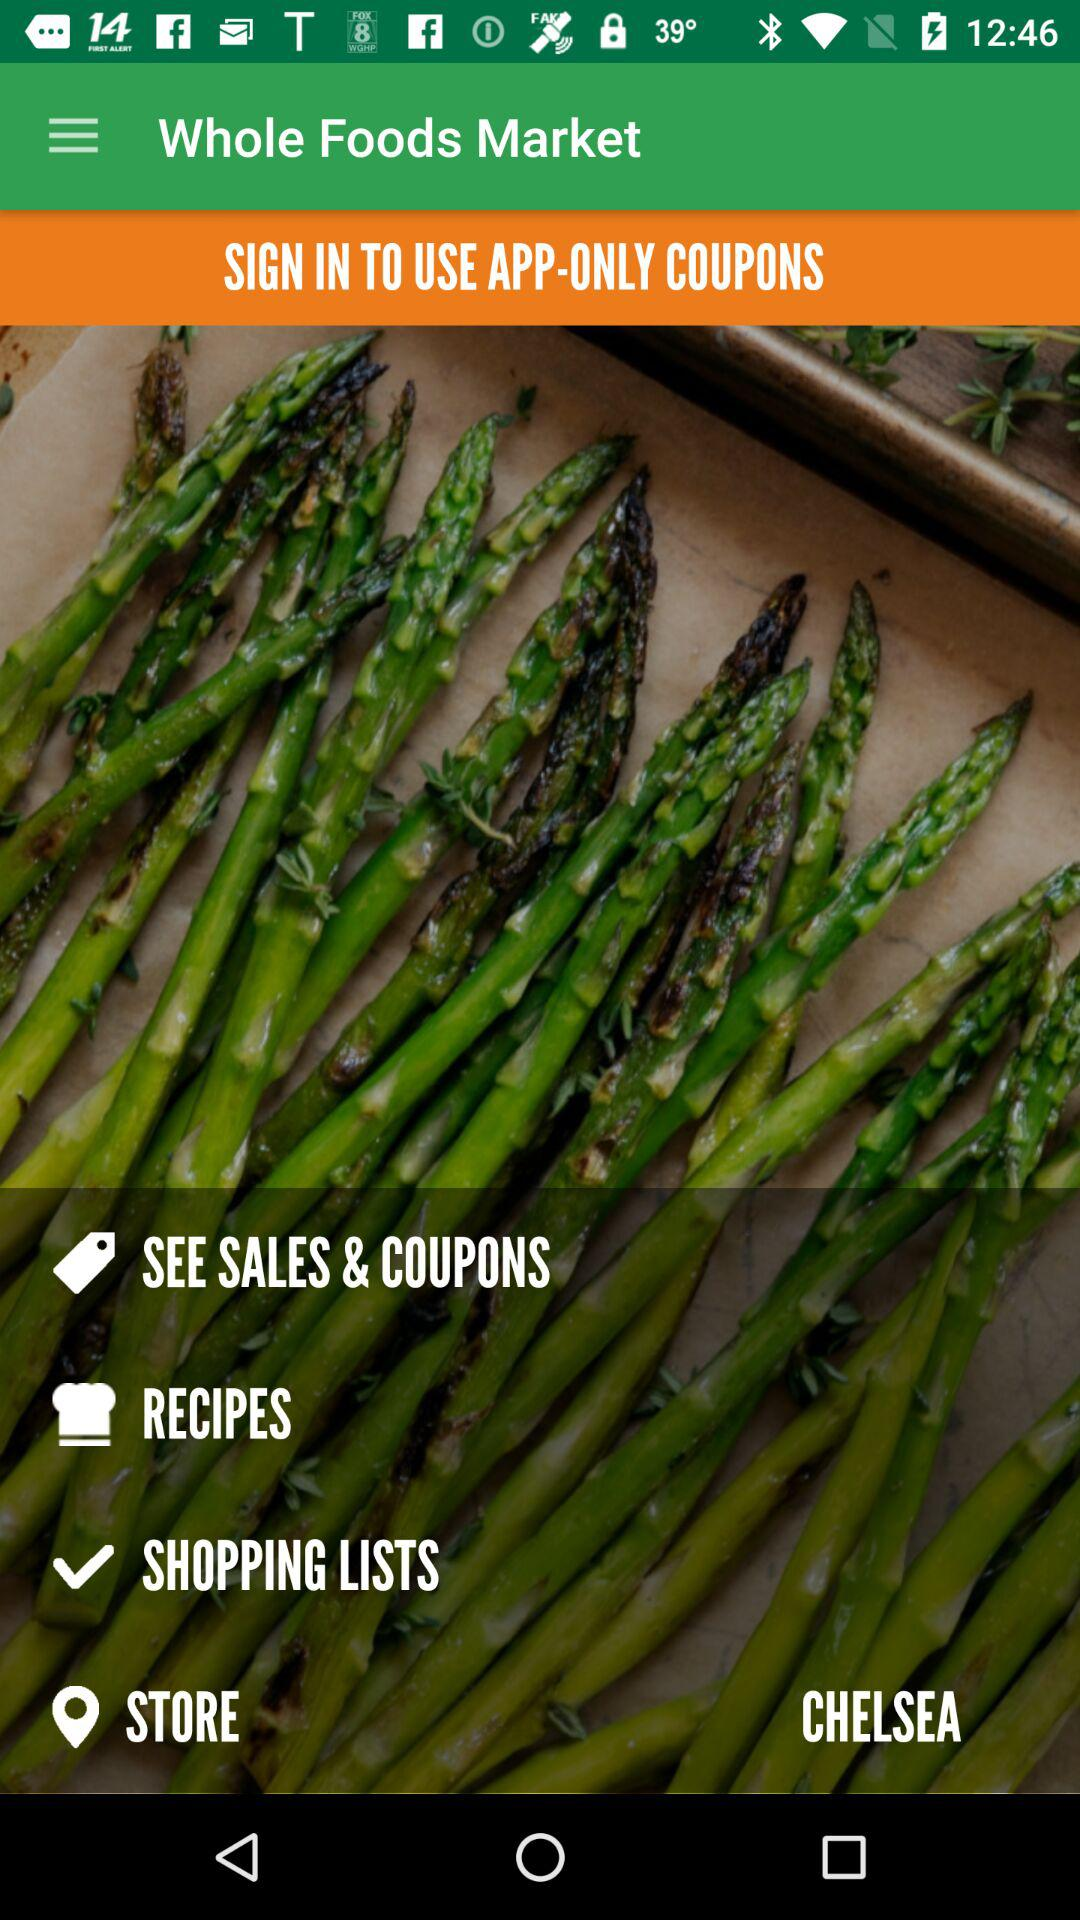What is the location of the store? The location of the store is Chelsea. 